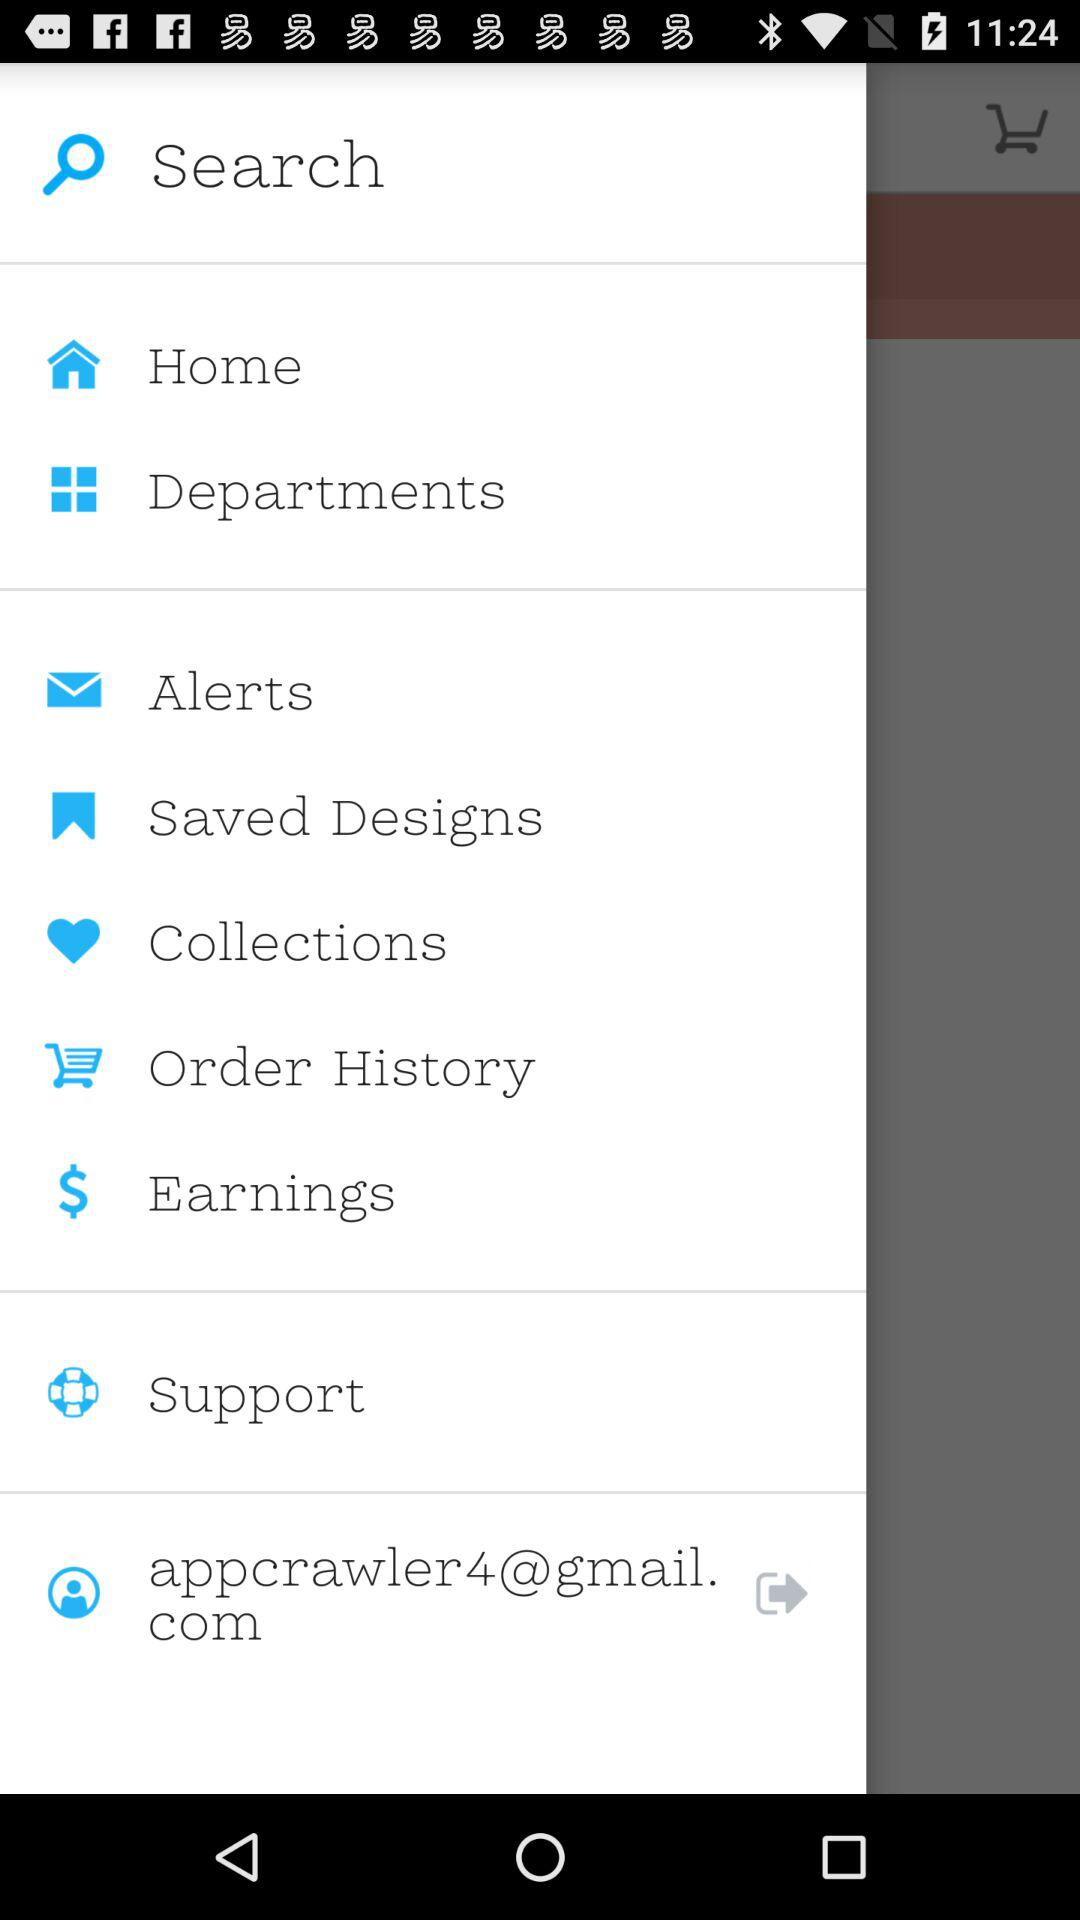What is the email address of the user? The email address is "appcrawler4@gmail.com". 